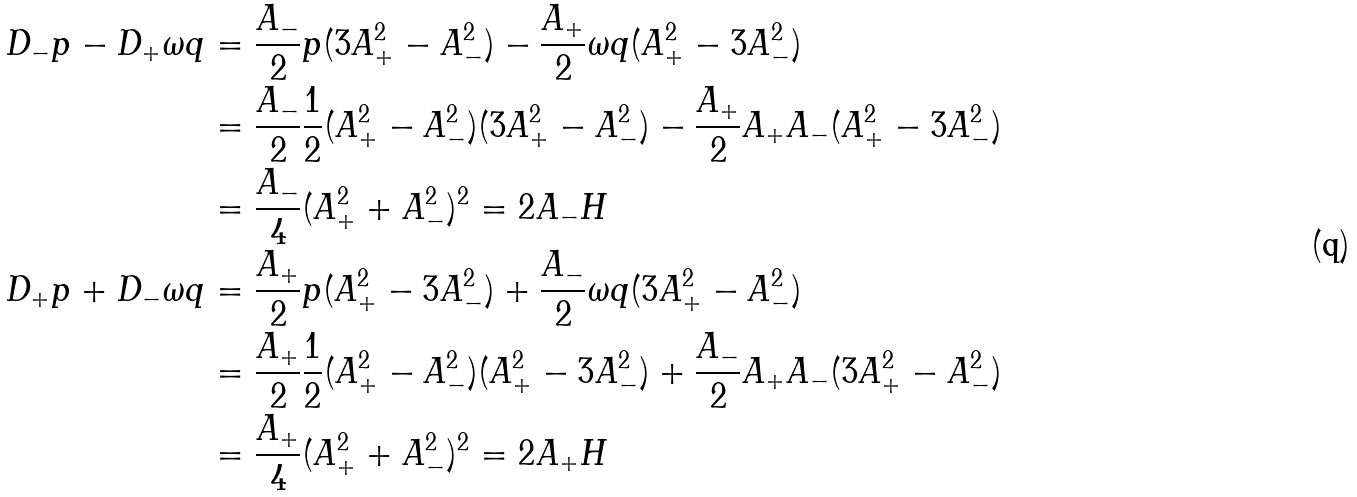<formula> <loc_0><loc_0><loc_500><loc_500>D _ { - } p - D _ { + } \omega q & = \frac { A _ { - } } { 2 } p ( 3 A _ { + } ^ { 2 } - A _ { - } ^ { 2 } ) - \frac { A _ { + } } { 2 } \omega q ( A _ { + } ^ { 2 } - 3 A _ { - } ^ { 2 } ) \\ & = \frac { A _ { - } } { 2 } \frac { 1 } { 2 } ( A _ { + } ^ { 2 } - A _ { - } ^ { 2 } ) ( 3 A _ { + } ^ { 2 } - A _ { - } ^ { 2 } ) - \frac { A _ { + } } { 2 } A _ { + } A _ { - } ( A _ { + } ^ { 2 } - 3 A _ { - } ^ { 2 } ) \\ & = \frac { A _ { - } } { 4 } ( A _ { + } ^ { 2 } + A _ { - } ^ { 2 } ) ^ { 2 } = 2 A _ { - } H \\ D _ { + } p + D _ { - } \omega q & = \frac { A _ { + } } { 2 } p ( A _ { + } ^ { 2 } - 3 A _ { - } ^ { 2 } ) + \frac { A _ { - } } { 2 } \omega q ( 3 A _ { + } ^ { 2 } - A _ { - } ^ { 2 } ) \\ & = \frac { A _ { + } } { 2 } \frac { 1 } { 2 } ( A _ { + } ^ { 2 } - A _ { - } ^ { 2 } ) ( A _ { + } ^ { 2 } - 3 A _ { - } ^ { 2 } ) + \frac { A _ { - } } { 2 } A _ { + } A _ { - } ( 3 A _ { + } ^ { 2 } - A _ { - } ^ { 2 } ) \\ & = \frac { A _ { + } } { 4 } ( A _ { + } ^ { 2 } + A _ { - } ^ { 2 } ) ^ { 2 } = 2 A _ { + } H \\</formula> 